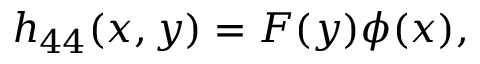Convert formula to latex. <formula><loc_0><loc_0><loc_500><loc_500>h _ { 4 4 } ( x , y ) = F ( y ) \phi ( x ) ,</formula> 